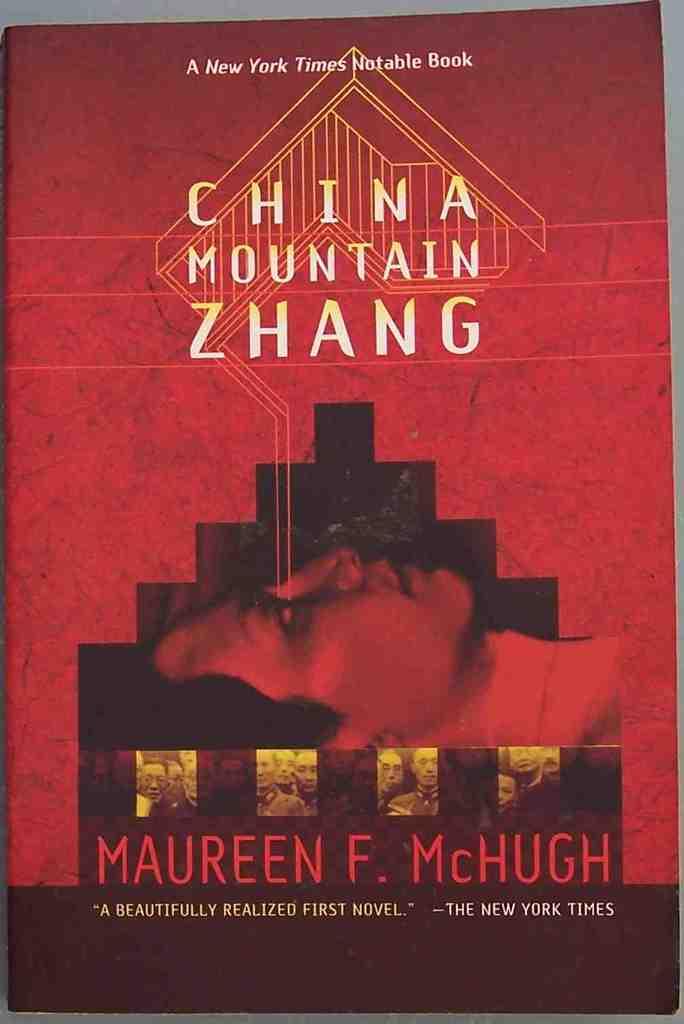What is the title of the book?
Provide a short and direct response. China mountain zhang. Who is the author?
Offer a terse response. Maureen f. mchugh. 